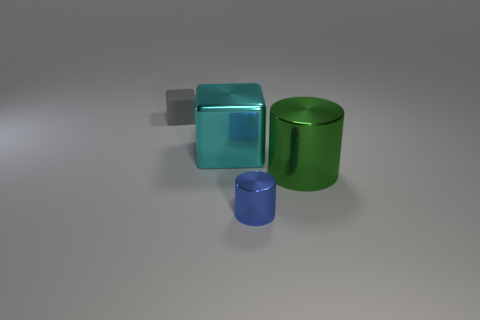Does the green shiny object have the same size as the blue thing?
Make the answer very short. No. The thing that is both on the left side of the large green shiny cylinder and on the right side of the large cyan metal block is what color?
Your answer should be very brief. Blue. There is a thing to the left of the metal object on the left side of the small object that is on the right side of the tiny gray block; what is its size?
Your answer should be compact. Small. What number of things are either metal cylinders behind the tiny blue metal object or large shiny objects that are in front of the shiny cube?
Your response must be concise. 1. There is a tiny metal object; what shape is it?
Give a very brief answer. Cylinder. How many other things are there of the same material as the blue object?
Provide a succinct answer. 2. What size is the green metal object that is the same shape as the blue metal thing?
Offer a very short reply. Large. What material is the cylinder on the left side of the metal thing that is on the right side of the metallic cylinder to the left of the big metallic cylinder?
Make the answer very short. Metal. Are there any big cyan objects?
Keep it short and to the point. Yes. There is a rubber block; does it have the same color as the metal thing in front of the big green metal cylinder?
Keep it short and to the point. No. 